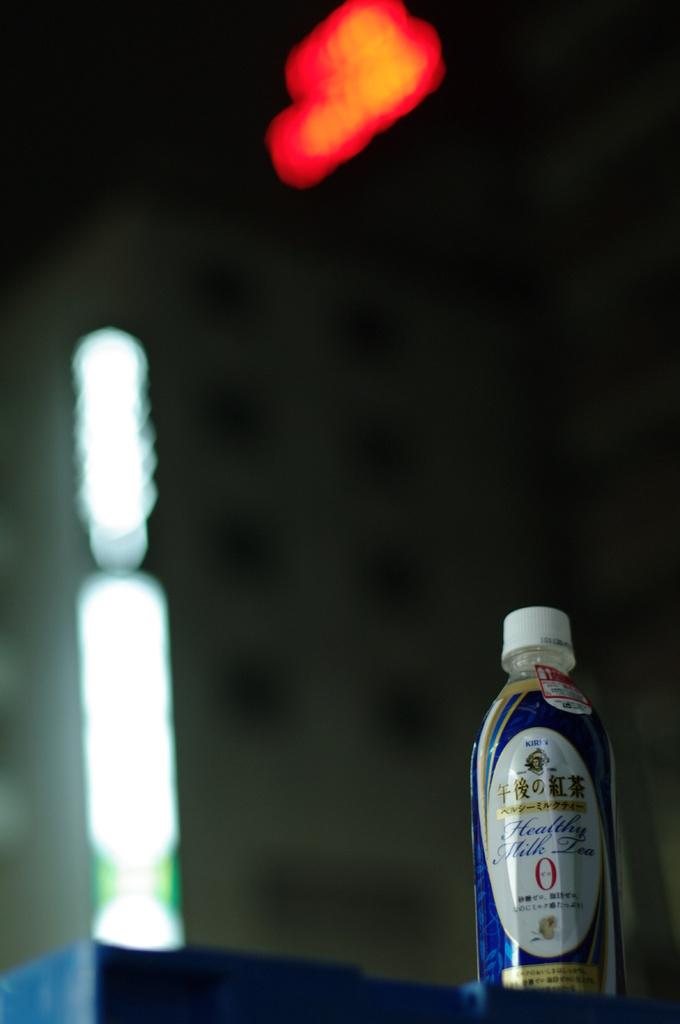What can be observed about the background of the image? The background of the image is blurry. What is visible at the top of the image? There is a light visible at the top of the image. What object is present on the table in the image? There is a bottle on the table. What color is the cap of the bottle? The bottle has a white cap. How does the star contribute to the image's composition? There is no star present in the image. What memory does the image evoke for the viewer? The image does not evoke a specific memory, as it only contains a blurry background, a light, a bottle, and a white cap. 